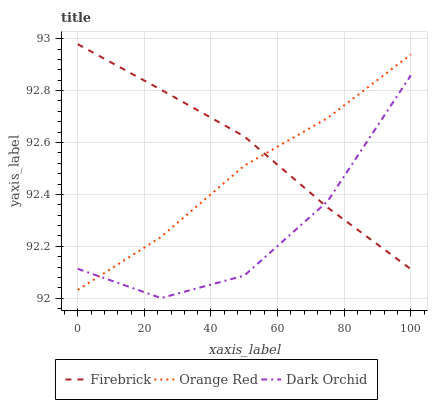Does Dark Orchid have the minimum area under the curve?
Answer yes or no. Yes. Does Firebrick have the maximum area under the curve?
Answer yes or no. Yes. Does Orange Red have the minimum area under the curve?
Answer yes or no. No. Does Orange Red have the maximum area under the curve?
Answer yes or no. No. Is Firebrick the smoothest?
Answer yes or no. Yes. Is Dark Orchid the roughest?
Answer yes or no. Yes. Is Orange Red the smoothest?
Answer yes or no. No. Is Orange Red the roughest?
Answer yes or no. No. Does Dark Orchid have the lowest value?
Answer yes or no. Yes. Does Orange Red have the lowest value?
Answer yes or no. No. Does Firebrick have the highest value?
Answer yes or no. Yes. Does Orange Red have the highest value?
Answer yes or no. No. Does Firebrick intersect Dark Orchid?
Answer yes or no. Yes. Is Firebrick less than Dark Orchid?
Answer yes or no. No. Is Firebrick greater than Dark Orchid?
Answer yes or no. No. 